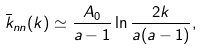<formula> <loc_0><loc_0><loc_500><loc_500>\bar { k } _ { n n } ( k ) \simeq \frac { A _ { 0 } } { a - 1 } \ln \frac { 2 k } { a ( a - 1 ) } ,</formula> 